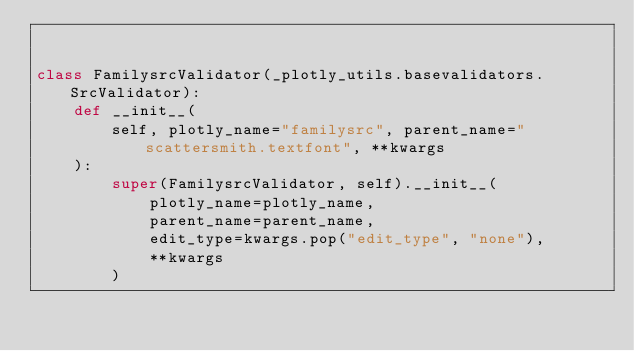Convert code to text. <code><loc_0><loc_0><loc_500><loc_500><_Python_>

class FamilysrcValidator(_plotly_utils.basevalidators.SrcValidator):
    def __init__(
        self, plotly_name="familysrc", parent_name="scattersmith.textfont", **kwargs
    ):
        super(FamilysrcValidator, self).__init__(
            plotly_name=plotly_name,
            parent_name=parent_name,
            edit_type=kwargs.pop("edit_type", "none"),
            **kwargs
        )
</code> 